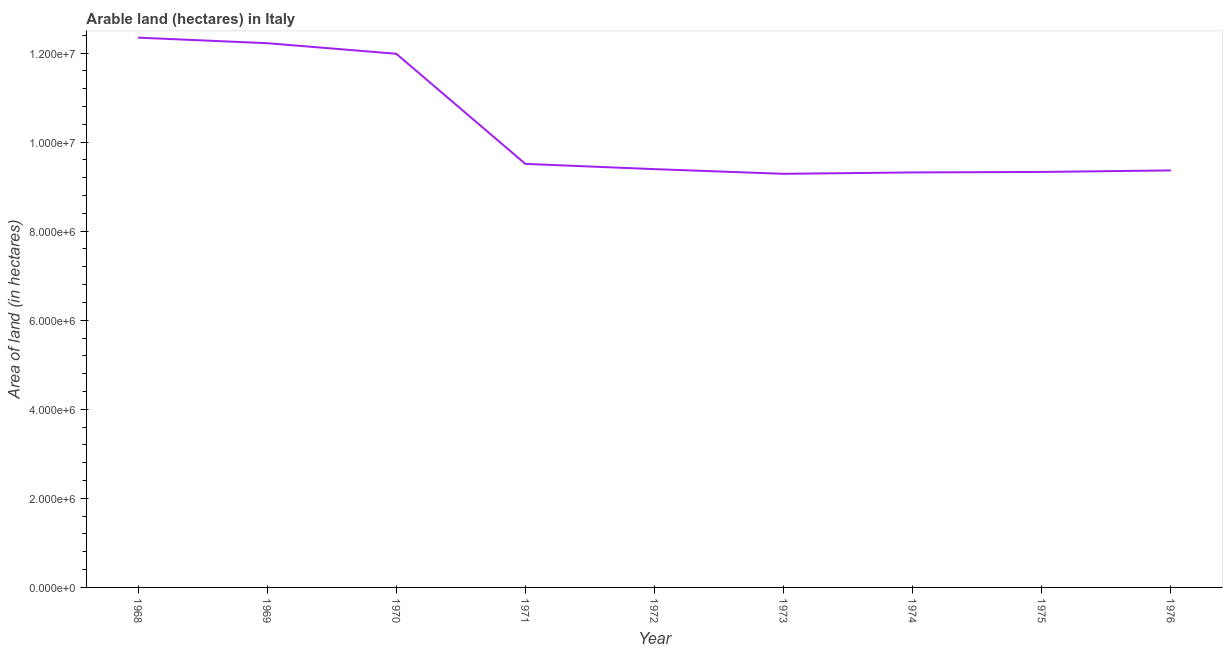What is the area of land in 1968?
Provide a succinct answer. 1.23e+07. Across all years, what is the maximum area of land?
Provide a short and direct response. 1.23e+07. Across all years, what is the minimum area of land?
Offer a terse response. 9.29e+06. In which year was the area of land maximum?
Your answer should be compact. 1968. What is the sum of the area of land?
Offer a terse response. 9.28e+07. What is the difference between the area of land in 1970 and 1976?
Provide a short and direct response. 2.62e+06. What is the average area of land per year?
Offer a very short reply. 1.03e+07. What is the median area of land?
Offer a terse response. 9.39e+06. Do a majority of the years between 1971 and 1976 (inclusive) have area of land greater than 2000000 hectares?
Provide a succinct answer. Yes. What is the ratio of the area of land in 1971 to that in 1975?
Provide a succinct answer. 1.02. Is the area of land in 1968 less than that in 1972?
Keep it short and to the point. No. Is the difference between the area of land in 1968 and 1972 greater than the difference between any two years?
Give a very brief answer. No. What is the difference between the highest and the second highest area of land?
Your answer should be very brief. 1.25e+05. Is the sum of the area of land in 1972 and 1976 greater than the maximum area of land across all years?
Keep it short and to the point. Yes. What is the difference between the highest and the lowest area of land?
Keep it short and to the point. 3.06e+06. Does the area of land monotonically increase over the years?
Your answer should be compact. No. How many lines are there?
Ensure brevity in your answer.  1. How many years are there in the graph?
Offer a very short reply. 9. What is the difference between two consecutive major ticks on the Y-axis?
Provide a succinct answer. 2.00e+06. Are the values on the major ticks of Y-axis written in scientific E-notation?
Provide a short and direct response. Yes. Does the graph contain any zero values?
Make the answer very short. No. Does the graph contain grids?
Give a very brief answer. No. What is the title of the graph?
Offer a terse response. Arable land (hectares) in Italy. What is the label or title of the Y-axis?
Offer a terse response. Area of land (in hectares). What is the Area of land (in hectares) in 1968?
Your response must be concise. 1.23e+07. What is the Area of land (in hectares) of 1969?
Offer a very short reply. 1.22e+07. What is the Area of land (in hectares) in 1970?
Offer a very short reply. 1.20e+07. What is the Area of land (in hectares) of 1971?
Offer a very short reply. 9.51e+06. What is the Area of land (in hectares) in 1972?
Ensure brevity in your answer.  9.39e+06. What is the Area of land (in hectares) of 1973?
Your answer should be compact. 9.29e+06. What is the Area of land (in hectares) in 1974?
Give a very brief answer. 9.32e+06. What is the Area of land (in hectares) of 1975?
Offer a terse response. 9.33e+06. What is the Area of land (in hectares) of 1976?
Provide a short and direct response. 9.36e+06. What is the difference between the Area of land (in hectares) in 1968 and 1969?
Provide a short and direct response. 1.25e+05. What is the difference between the Area of land (in hectares) in 1968 and 1970?
Give a very brief answer. 3.62e+05. What is the difference between the Area of land (in hectares) in 1968 and 1971?
Give a very brief answer. 2.84e+06. What is the difference between the Area of land (in hectares) in 1968 and 1972?
Ensure brevity in your answer.  2.95e+06. What is the difference between the Area of land (in hectares) in 1968 and 1973?
Provide a succinct answer. 3.06e+06. What is the difference between the Area of land (in hectares) in 1968 and 1974?
Your answer should be very brief. 3.03e+06. What is the difference between the Area of land (in hectares) in 1968 and 1975?
Your answer should be compact. 3.02e+06. What is the difference between the Area of land (in hectares) in 1968 and 1976?
Provide a succinct answer. 2.98e+06. What is the difference between the Area of land (in hectares) in 1969 and 1970?
Provide a short and direct response. 2.37e+05. What is the difference between the Area of land (in hectares) in 1969 and 1971?
Keep it short and to the point. 2.71e+06. What is the difference between the Area of land (in hectares) in 1969 and 1972?
Give a very brief answer. 2.83e+06. What is the difference between the Area of land (in hectares) in 1969 and 1973?
Offer a very short reply. 2.93e+06. What is the difference between the Area of land (in hectares) in 1969 and 1974?
Provide a short and direct response. 2.90e+06. What is the difference between the Area of land (in hectares) in 1969 and 1975?
Make the answer very short. 2.89e+06. What is the difference between the Area of land (in hectares) in 1969 and 1976?
Your answer should be very brief. 2.86e+06. What is the difference between the Area of land (in hectares) in 1970 and 1971?
Your answer should be very brief. 2.47e+06. What is the difference between the Area of land (in hectares) in 1970 and 1972?
Make the answer very short. 2.59e+06. What is the difference between the Area of land (in hectares) in 1970 and 1973?
Your answer should be very brief. 2.70e+06. What is the difference between the Area of land (in hectares) in 1970 and 1974?
Provide a short and direct response. 2.66e+06. What is the difference between the Area of land (in hectares) in 1970 and 1975?
Make the answer very short. 2.65e+06. What is the difference between the Area of land (in hectares) in 1970 and 1976?
Offer a terse response. 2.62e+06. What is the difference between the Area of land (in hectares) in 1971 and 1972?
Provide a short and direct response. 1.18e+05. What is the difference between the Area of land (in hectares) in 1971 and 1973?
Make the answer very short. 2.23e+05. What is the difference between the Area of land (in hectares) in 1971 and 1974?
Make the answer very short. 1.92e+05. What is the difference between the Area of land (in hectares) in 1971 and 1975?
Offer a terse response. 1.81e+05. What is the difference between the Area of land (in hectares) in 1971 and 1976?
Keep it short and to the point. 1.47e+05. What is the difference between the Area of land (in hectares) in 1972 and 1973?
Your response must be concise. 1.05e+05. What is the difference between the Area of land (in hectares) in 1972 and 1974?
Offer a very short reply. 7.40e+04. What is the difference between the Area of land (in hectares) in 1972 and 1975?
Ensure brevity in your answer.  6.30e+04. What is the difference between the Area of land (in hectares) in 1972 and 1976?
Offer a very short reply. 2.90e+04. What is the difference between the Area of land (in hectares) in 1973 and 1974?
Provide a succinct answer. -3.10e+04. What is the difference between the Area of land (in hectares) in 1973 and 1975?
Your answer should be very brief. -4.20e+04. What is the difference between the Area of land (in hectares) in 1973 and 1976?
Offer a terse response. -7.60e+04. What is the difference between the Area of land (in hectares) in 1974 and 1975?
Your answer should be very brief. -1.10e+04. What is the difference between the Area of land (in hectares) in 1974 and 1976?
Keep it short and to the point. -4.50e+04. What is the difference between the Area of land (in hectares) in 1975 and 1976?
Keep it short and to the point. -3.40e+04. What is the ratio of the Area of land (in hectares) in 1968 to that in 1969?
Keep it short and to the point. 1.01. What is the ratio of the Area of land (in hectares) in 1968 to that in 1971?
Keep it short and to the point. 1.3. What is the ratio of the Area of land (in hectares) in 1968 to that in 1972?
Provide a short and direct response. 1.31. What is the ratio of the Area of land (in hectares) in 1968 to that in 1973?
Ensure brevity in your answer.  1.33. What is the ratio of the Area of land (in hectares) in 1968 to that in 1974?
Give a very brief answer. 1.32. What is the ratio of the Area of land (in hectares) in 1968 to that in 1975?
Give a very brief answer. 1.32. What is the ratio of the Area of land (in hectares) in 1968 to that in 1976?
Your answer should be very brief. 1.32. What is the ratio of the Area of land (in hectares) in 1969 to that in 1970?
Give a very brief answer. 1.02. What is the ratio of the Area of land (in hectares) in 1969 to that in 1971?
Your response must be concise. 1.28. What is the ratio of the Area of land (in hectares) in 1969 to that in 1972?
Offer a very short reply. 1.3. What is the ratio of the Area of land (in hectares) in 1969 to that in 1973?
Your answer should be compact. 1.32. What is the ratio of the Area of land (in hectares) in 1969 to that in 1974?
Make the answer very short. 1.31. What is the ratio of the Area of land (in hectares) in 1969 to that in 1975?
Offer a terse response. 1.31. What is the ratio of the Area of land (in hectares) in 1969 to that in 1976?
Give a very brief answer. 1.3. What is the ratio of the Area of land (in hectares) in 1970 to that in 1971?
Keep it short and to the point. 1.26. What is the ratio of the Area of land (in hectares) in 1970 to that in 1972?
Ensure brevity in your answer.  1.28. What is the ratio of the Area of land (in hectares) in 1970 to that in 1973?
Make the answer very short. 1.29. What is the ratio of the Area of land (in hectares) in 1970 to that in 1974?
Offer a very short reply. 1.29. What is the ratio of the Area of land (in hectares) in 1970 to that in 1975?
Your answer should be compact. 1.28. What is the ratio of the Area of land (in hectares) in 1970 to that in 1976?
Make the answer very short. 1.28. What is the ratio of the Area of land (in hectares) in 1971 to that in 1972?
Keep it short and to the point. 1.01. What is the ratio of the Area of land (in hectares) in 1971 to that in 1974?
Give a very brief answer. 1.02. What is the ratio of the Area of land (in hectares) in 1971 to that in 1975?
Provide a short and direct response. 1.02. What is the ratio of the Area of land (in hectares) in 1972 to that in 1973?
Your response must be concise. 1.01. What is the ratio of the Area of land (in hectares) in 1972 to that in 1974?
Keep it short and to the point. 1.01. What is the ratio of the Area of land (in hectares) in 1972 to that in 1976?
Give a very brief answer. 1. What is the ratio of the Area of land (in hectares) in 1973 to that in 1974?
Ensure brevity in your answer.  1. What is the ratio of the Area of land (in hectares) in 1975 to that in 1976?
Give a very brief answer. 1. 